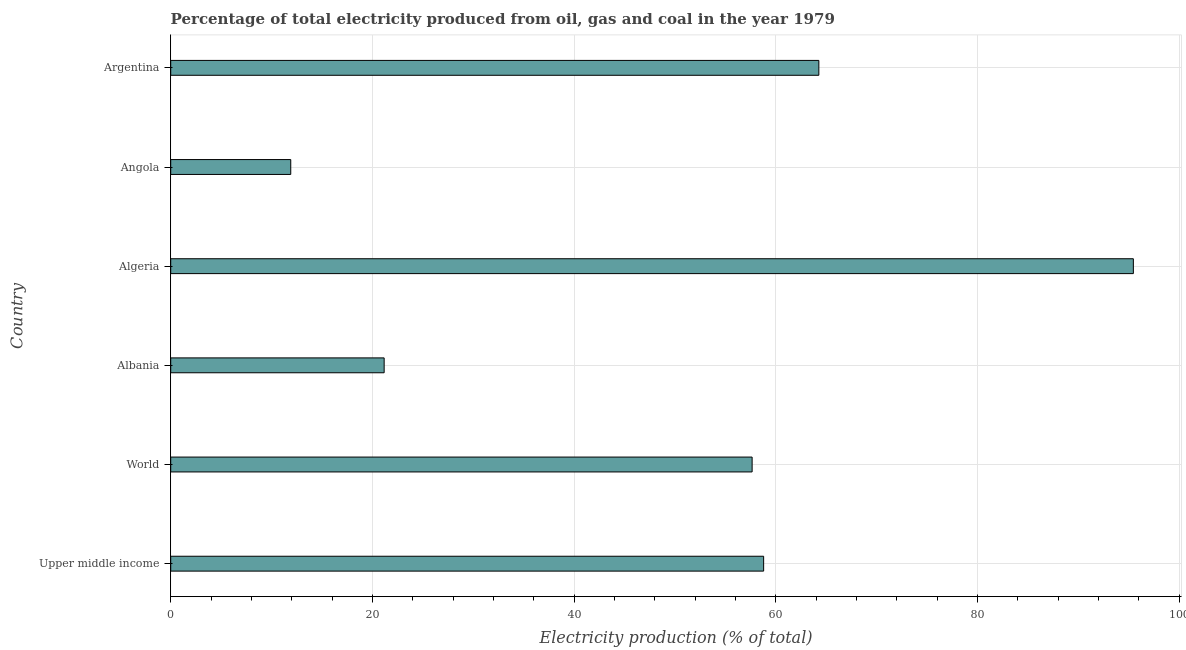Does the graph contain any zero values?
Your answer should be very brief. No. What is the title of the graph?
Offer a terse response. Percentage of total electricity produced from oil, gas and coal in the year 1979. What is the label or title of the X-axis?
Provide a succinct answer. Electricity production (% of total). What is the label or title of the Y-axis?
Keep it short and to the point. Country. What is the electricity production in Albania?
Keep it short and to the point. 21.17. Across all countries, what is the maximum electricity production?
Make the answer very short. 95.47. Across all countries, what is the minimum electricity production?
Keep it short and to the point. 11.9. In which country was the electricity production maximum?
Your answer should be compact. Algeria. In which country was the electricity production minimum?
Ensure brevity in your answer.  Angola. What is the sum of the electricity production?
Give a very brief answer. 309.3. What is the difference between the electricity production in Albania and Upper middle income?
Your response must be concise. -37.64. What is the average electricity production per country?
Provide a short and direct response. 51.55. What is the median electricity production?
Your answer should be very brief. 58.23. In how many countries, is the electricity production greater than 40 %?
Provide a succinct answer. 4. What is the ratio of the electricity production in Albania to that in Argentina?
Your response must be concise. 0.33. What is the difference between the highest and the second highest electricity production?
Ensure brevity in your answer.  31.19. What is the difference between the highest and the lowest electricity production?
Your answer should be compact. 83.57. How many bars are there?
Ensure brevity in your answer.  6. Are all the bars in the graph horizontal?
Provide a succinct answer. Yes. How many countries are there in the graph?
Your response must be concise. 6. What is the difference between two consecutive major ticks on the X-axis?
Make the answer very short. 20. Are the values on the major ticks of X-axis written in scientific E-notation?
Provide a short and direct response. No. What is the Electricity production (% of total) of Upper middle income?
Keep it short and to the point. 58.81. What is the Electricity production (% of total) of World?
Ensure brevity in your answer.  57.66. What is the Electricity production (% of total) in Albania?
Offer a very short reply. 21.17. What is the Electricity production (% of total) of Algeria?
Provide a succinct answer. 95.47. What is the Electricity production (% of total) of Angola?
Offer a very short reply. 11.9. What is the Electricity production (% of total) in Argentina?
Your answer should be very brief. 64.28. What is the difference between the Electricity production (% of total) in Upper middle income and World?
Keep it short and to the point. 1.14. What is the difference between the Electricity production (% of total) in Upper middle income and Albania?
Offer a very short reply. 37.64. What is the difference between the Electricity production (% of total) in Upper middle income and Algeria?
Provide a succinct answer. -36.67. What is the difference between the Electricity production (% of total) in Upper middle income and Angola?
Make the answer very short. 46.9. What is the difference between the Electricity production (% of total) in Upper middle income and Argentina?
Provide a succinct answer. -5.48. What is the difference between the Electricity production (% of total) in World and Albania?
Ensure brevity in your answer.  36.5. What is the difference between the Electricity production (% of total) in World and Algeria?
Offer a very short reply. -37.81. What is the difference between the Electricity production (% of total) in World and Angola?
Ensure brevity in your answer.  45.76. What is the difference between the Electricity production (% of total) in World and Argentina?
Provide a short and direct response. -6.62. What is the difference between the Electricity production (% of total) in Albania and Algeria?
Ensure brevity in your answer.  -74.31. What is the difference between the Electricity production (% of total) in Albania and Angola?
Your response must be concise. 9.26. What is the difference between the Electricity production (% of total) in Albania and Argentina?
Offer a very short reply. -43.11. What is the difference between the Electricity production (% of total) in Algeria and Angola?
Your answer should be compact. 83.57. What is the difference between the Electricity production (% of total) in Algeria and Argentina?
Offer a very short reply. 31.19. What is the difference between the Electricity production (% of total) in Angola and Argentina?
Make the answer very short. -52.38. What is the ratio of the Electricity production (% of total) in Upper middle income to that in World?
Your answer should be compact. 1.02. What is the ratio of the Electricity production (% of total) in Upper middle income to that in Albania?
Offer a very short reply. 2.78. What is the ratio of the Electricity production (% of total) in Upper middle income to that in Algeria?
Your answer should be compact. 0.62. What is the ratio of the Electricity production (% of total) in Upper middle income to that in Angola?
Your response must be concise. 4.94. What is the ratio of the Electricity production (% of total) in Upper middle income to that in Argentina?
Offer a very short reply. 0.92. What is the ratio of the Electricity production (% of total) in World to that in Albania?
Make the answer very short. 2.72. What is the ratio of the Electricity production (% of total) in World to that in Algeria?
Offer a very short reply. 0.6. What is the ratio of the Electricity production (% of total) in World to that in Angola?
Keep it short and to the point. 4.84. What is the ratio of the Electricity production (% of total) in World to that in Argentina?
Keep it short and to the point. 0.9. What is the ratio of the Electricity production (% of total) in Albania to that in Algeria?
Your answer should be compact. 0.22. What is the ratio of the Electricity production (% of total) in Albania to that in Angola?
Your answer should be compact. 1.78. What is the ratio of the Electricity production (% of total) in Albania to that in Argentina?
Your answer should be compact. 0.33. What is the ratio of the Electricity production (% of total) in Algeria to that in Angola?
Your response must be concise. 8.02. What is the ratio of the Electricity production (% of total) in Algeria to that in Argentina?
Your response must be concise. 1.49. What is the ratio of the Electricity production (% of total) in Angola to that in Argentina?
Keep it short and to the point. 0.18. 